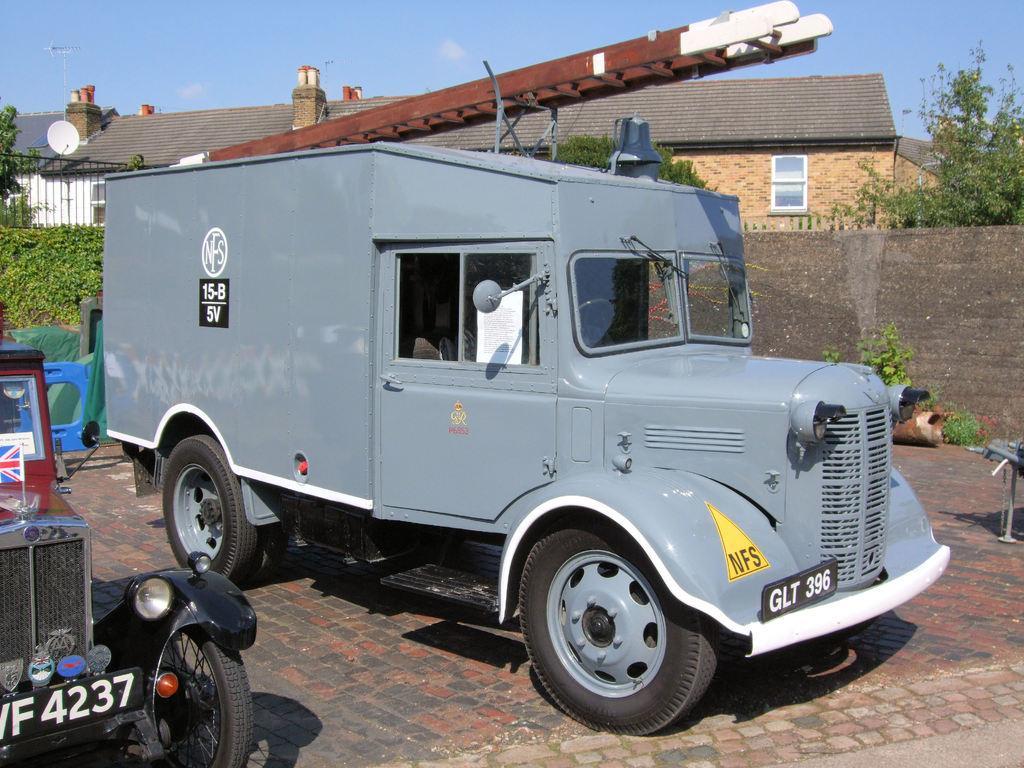Please provide a concise description of this image. In the center of the image we can see vehicle on the floor. On the left side of the image we can see car. On the right side of the image we can see wall, tree. In the background we can see buildings, sky and clouds. 